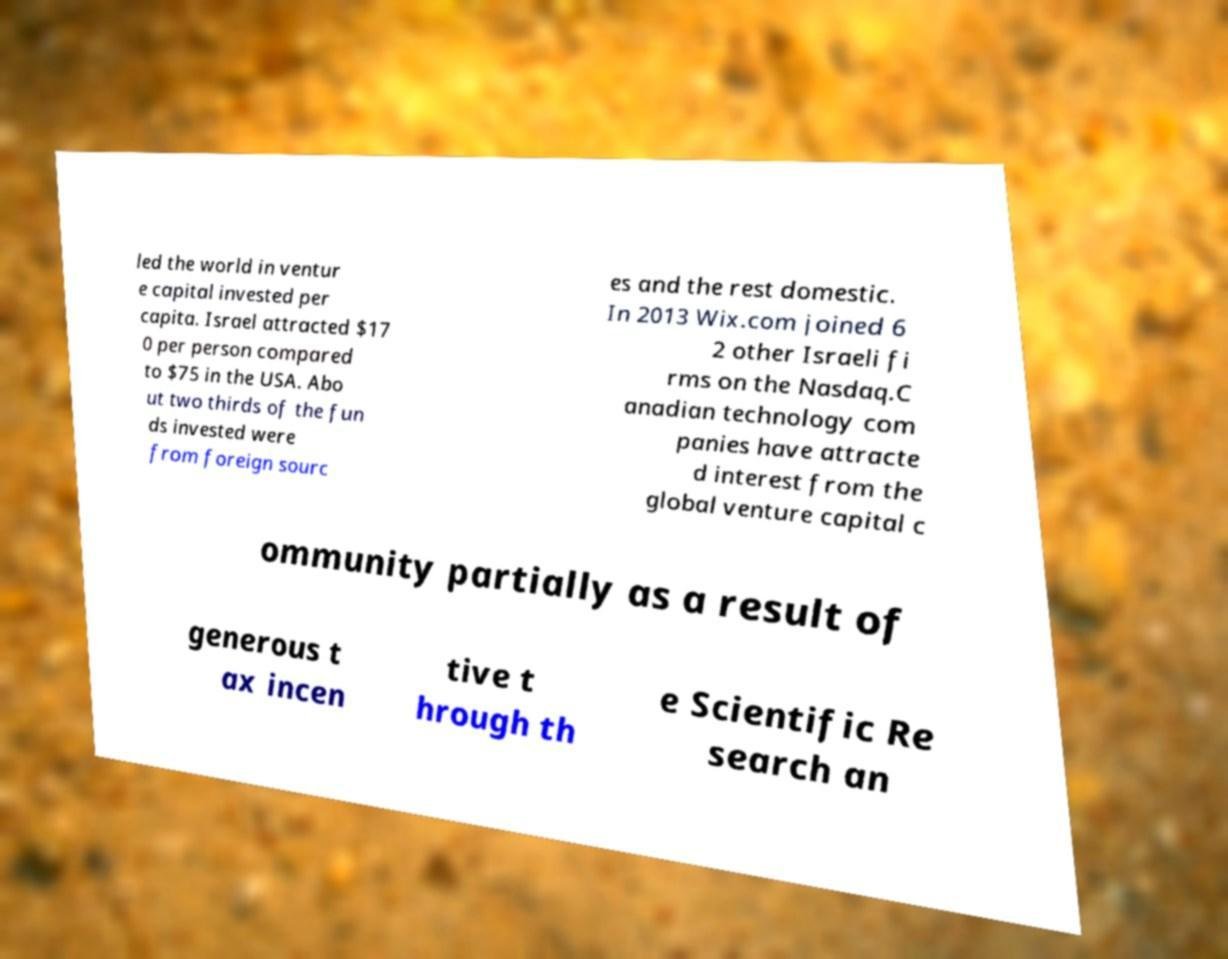Could you assist in decoding the text presented in this image and type it out clearly? led the world in ventur e capital invested per capita. Israel attracted $17 0 per person compared to $75 in the USA. Abo ut two thirds of the fun ds invested were from foreign sourc es and the rest domestic. In 2013 Wix.com joined 6 2 other Israeli fi rms on the Nasdaq.C anadian technology com panies have attracte d interest from the global venture capital c ommunity partially as a result of generous t ax incen tive t hrough th e Scientific Re search an 